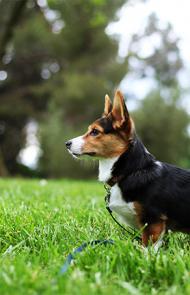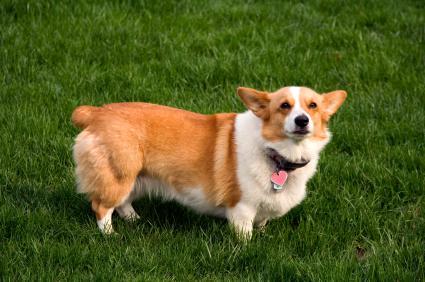The first image is the image on the left, the second image is the image on the right. For the images shown, is this caption "An image includes an orange-and-white dog walking toward the camera on grass." true? Answer yes or no. No. 